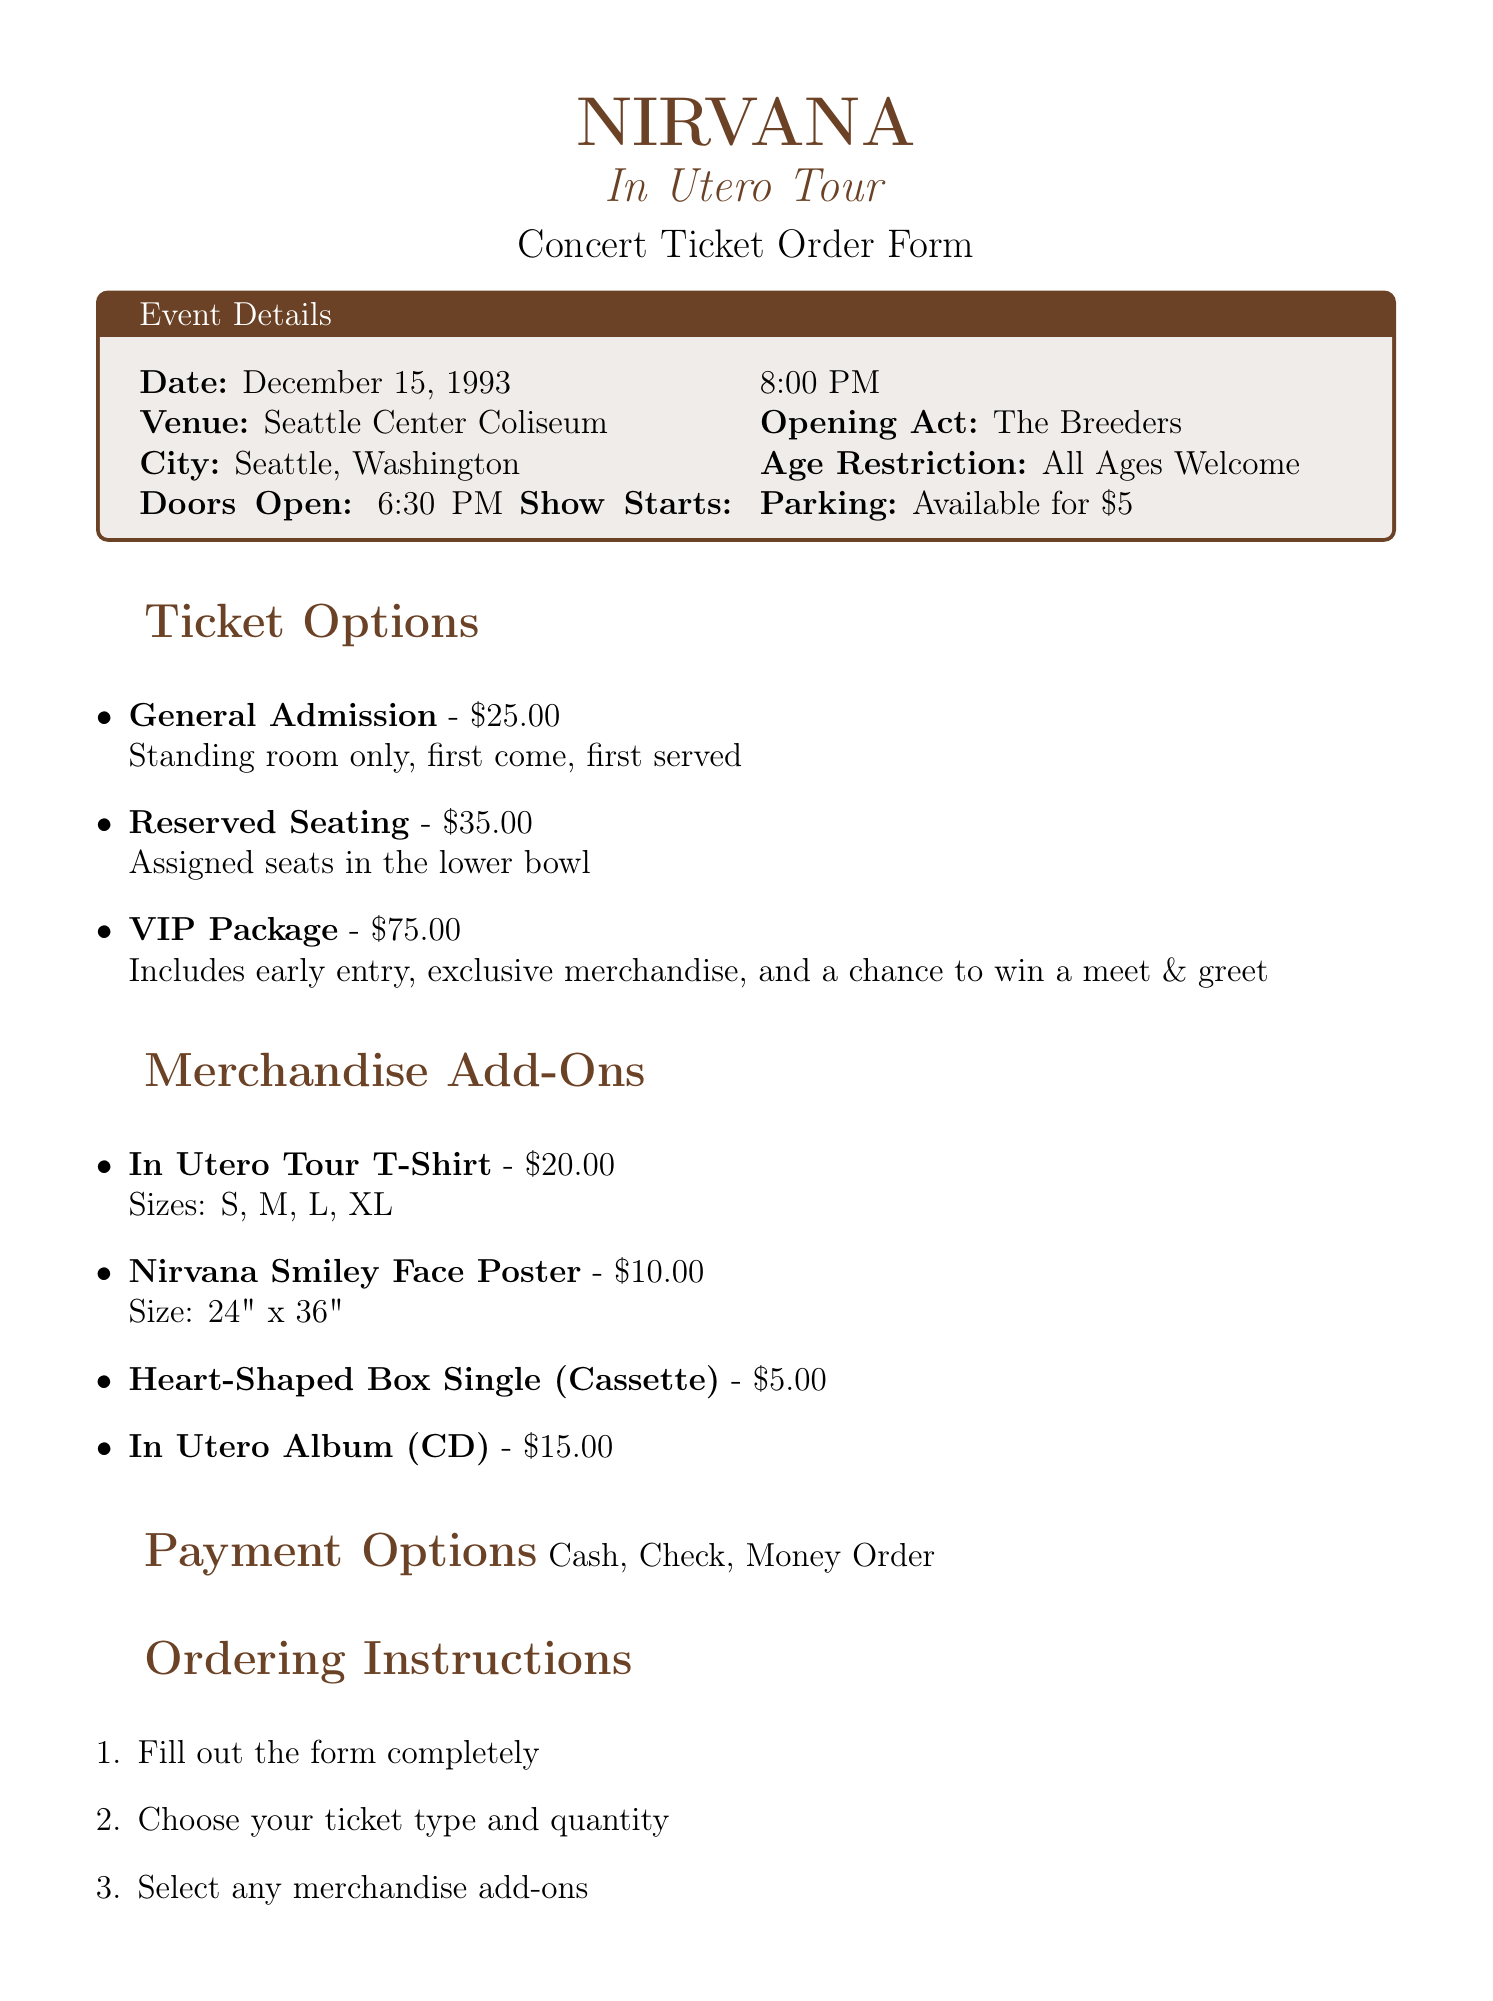what is the name of the band performing? The document states the name of the band that is performing at the concert, which is Nirvana.
Answer: Nirvana what is the date of the concert? The specific date when the concert is taking place is mentioned in the document.
Answer: December 15, 1993 how much is the VIP Package ticket? The document lists the pricing for different ticket options; the price for the VIP Package is specified.
Answer: 75.00 what is the maximum number of tickets one person can purchase? The additional information section includes the limit for ticket purchases per person.
Answer: 4 what merchandise item costs 15.00? The document lists several merchandise options along with their prices; one item is specifically priced at 15.00.
Answer: In Utero Album which parking facility is mentioned in the document? The document includes information about parking availability.
Answer: Seattle Center what is the opening act for the concert? The document states who will be performing as the opening act during the concert event.
Answer: The Breeders what payment methods are accepted? The document gives a list of acceptable payment options for the ticket order.
Answer: Cash, Check, Money Order where should the order form be mailed? The ordering instructions specify the address for mailing the completed order form.
Answer: Sub Pop Records, PO Box 20645, Seattle, WA 98102 